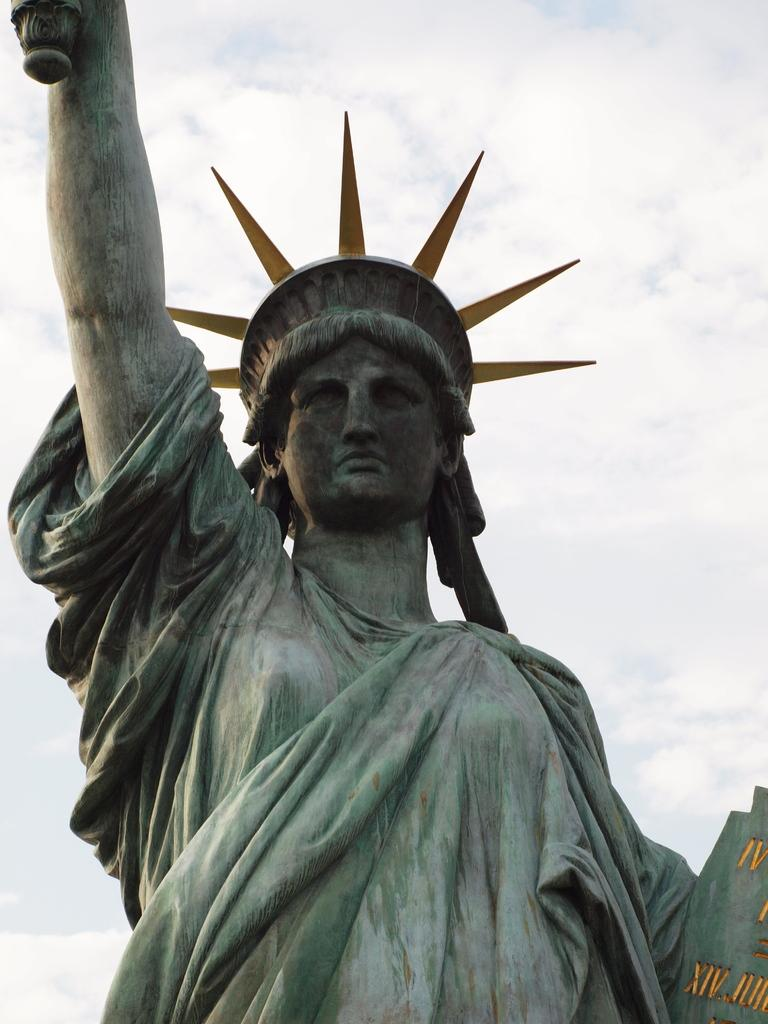What is the main subject in the image? There is a statue in the image. What can be seen in the background of the image? There are clouds visible in the background of the image. What type of worm can be seen crawling on the statue in the image? There is no worm present on the statue in the image. What type of grape can be seen hanging from the clouds in the background of the image? There is no grape present in the image, and the clouds are not holding any grapes. 